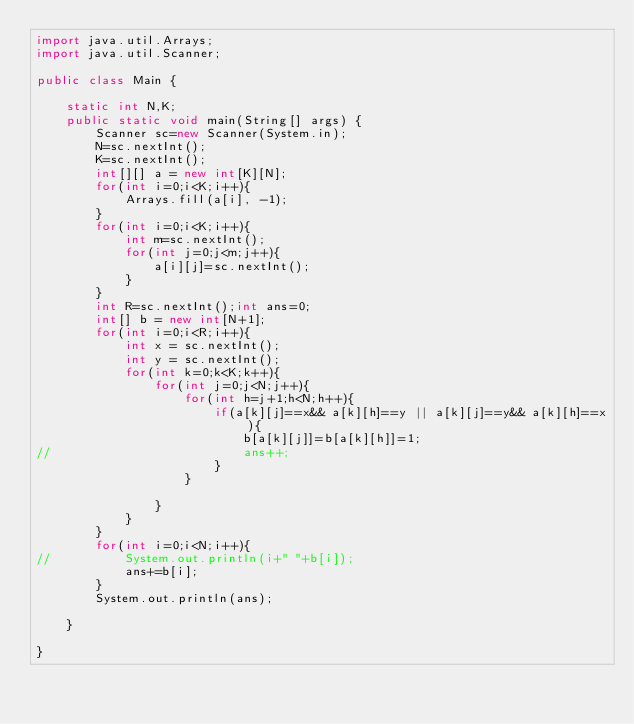<code> <loc_0><loc_0><loc_500><loc_500><_Java_>import java.util.Arrays;
import java.util.Scanner;

public class Main {

	static int N,K;
	public static void main(String[] args) {
		Scanner sc=new Scanner(System.in);
		N=sc.nextInt();
		K=sc.nextInt();
		int[][] a = new int[K][N];
		for(int i=0;i<K;i++){
			Arrays.fill(a[i], -1);
		}
		for(int i=0;i<K;i++){
			int m=sc.nextInt();
			for(int j=0;j<m;j++){
				a[i][j]=sc.nextInt();
			}
		}
		int R=sc.nextInt();int ans=0;
		int[] b = new int[N+1];
		for(int i=0;i<R;i++){
			int x = sc.nextInt();
			int y = sc.nextInt();
			for(int k=0;k<K;k++){
				for(int j=0;j<N;j++){
					for(int h=j+1;h<N;h++){
						if(a[k][j]==x&& a[k][h]==y || a[k][j]==y&& a[k][h]==x){
							b[a[k][j]]=b[a[k][h]]=1;
//							ans++;
						}
					}
					
				}
			}
		}
		for(int i=0;i<N;i++){
//			System.out.println(i+" "+b[i]);
			ans+=b[i];
		}
		System.out.println(ans);
		
	}

}</code> 